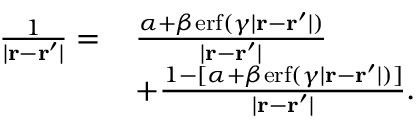<formula> <loc_0><loc_0><loc_500><loc_500>\begin{array} { r l } { \frac { 1 } { | r - r ^ { \prime } | } = \, } & { \frac { \alpha + \beta e r f ( \gamma | r - r ^ { \prime } | ) } { | r - r ^ { \prime } | } } \\ & { + \frac { 1 - [ \alpha + \beta e r f ( \gamma | r - r ^ { \prime } | ) ] } { | r - r ^ { \prime } | } . } \end{array}</formula> 